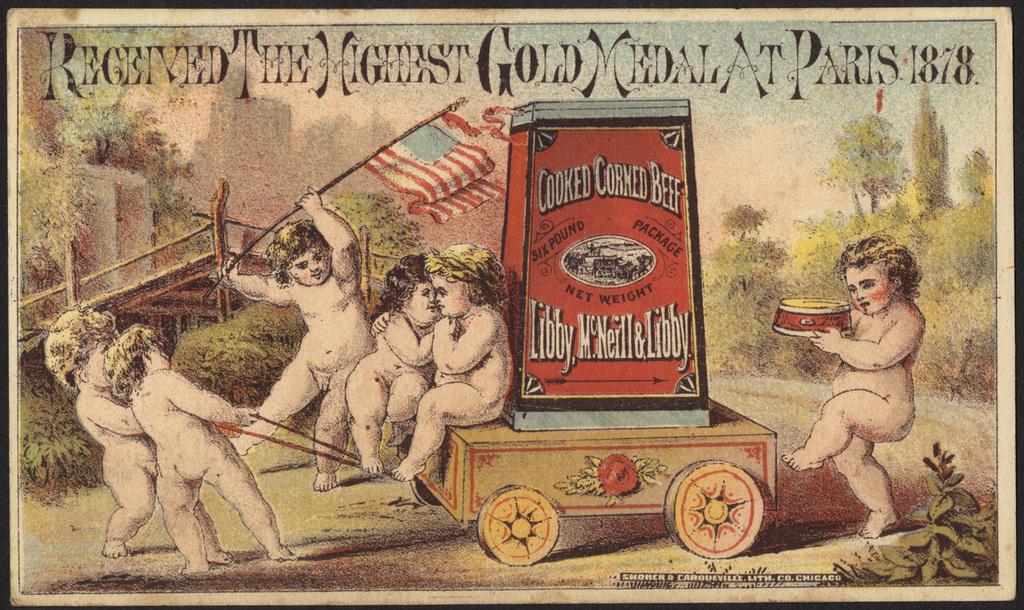What is the date on this drawing?
Provide a succinct answer. 1878. 